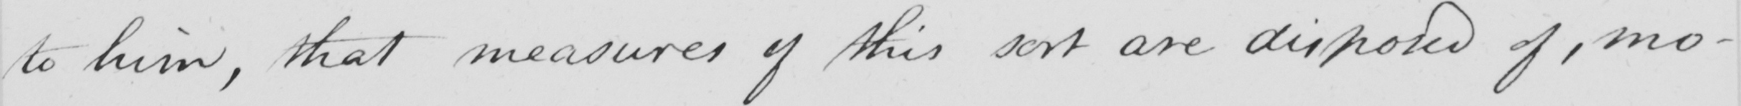Can you tell me what this handwritten text says? to him, that measures of this sort are disposed of, mo- 